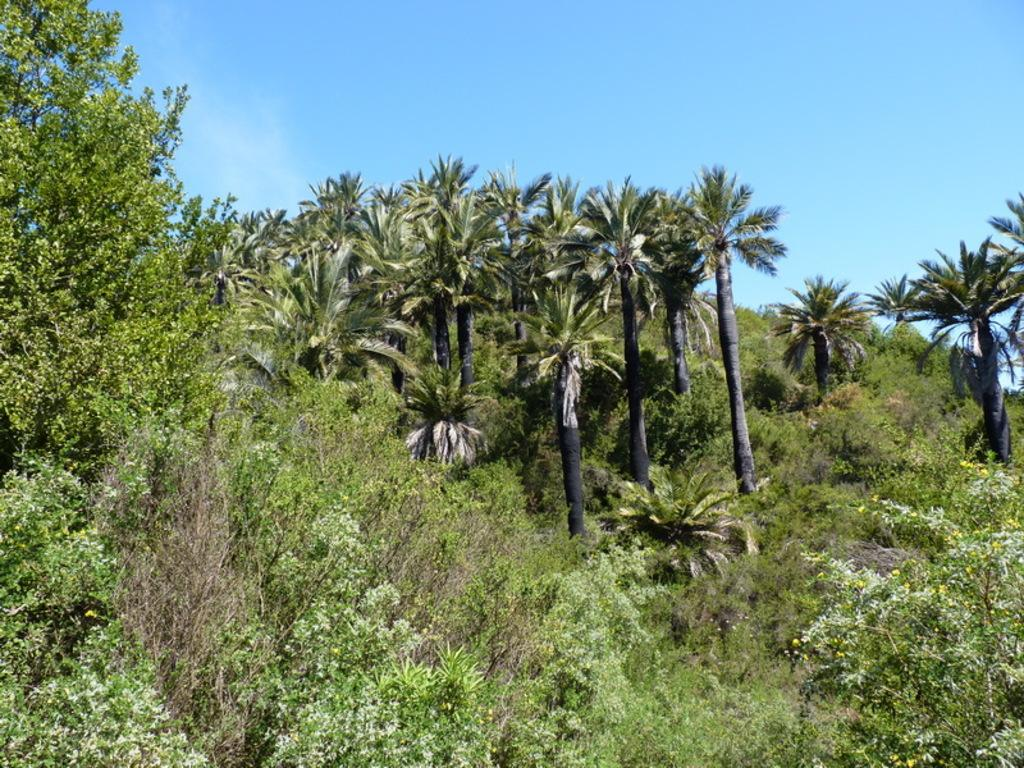What type of vegetation can be seen in the image? There are trees and plants in the image. Can you describe the natural elements present in the image? The image features trees and plants, which are both natural elements. What type of furniture can be seen in the image? There is no furniture present in the image; it only features trees and plants. Can you hear a whistle in the image? There is no sound or indication of a whistle in the image, as it is a still image. 